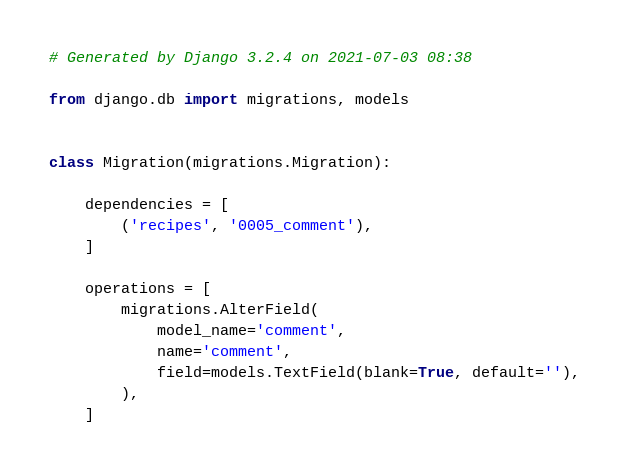<code> <loc_0><loc_0><loc_500><loc_500><_Python_># Generated by Django 3.2.4 on 2021-07-03 08:38

from django.db import migrations, models


class Migration(migrations.Migration):

    dependencies = [
        ('recipes', '0005_comment'),
    ]

    operations = [
        migrations.AlterField(
            model_name='comment',
            name='comment',
            field=models.TextField(blank=True, default=''),
        ),
    ]
</code> 